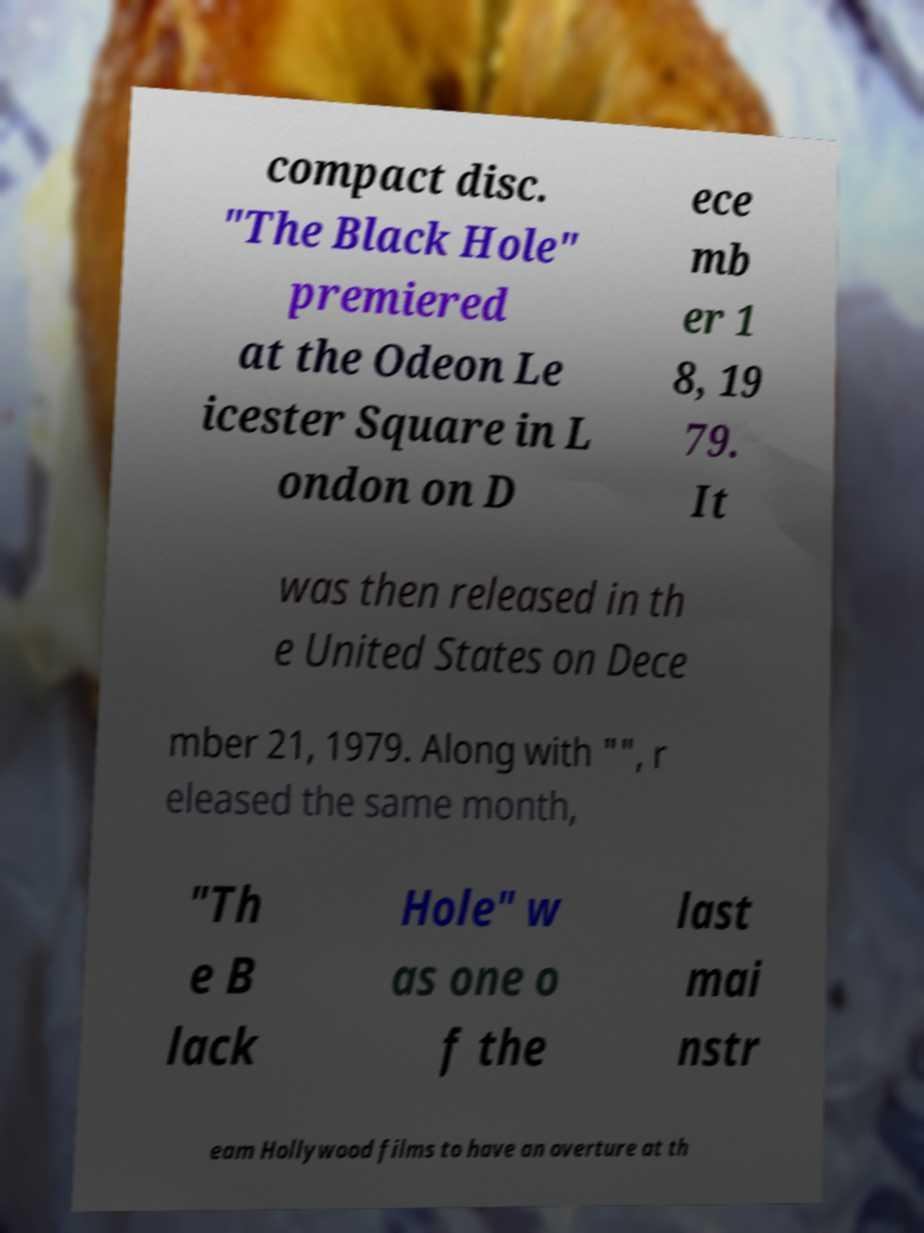Can you accurately transcribe the text from the provided image for me? compact disc. "The Black Hole" premiered at the Odeon Le icester Square in L ondon on D ece mb er 1 8, 19 79. It was then released in th e United States on Dece mber 21, 1979. Along with "", r eleased the same month, "Th e B lack Hole" w as one o f the last mai nstr eam Hollywood films to have an overture at th 